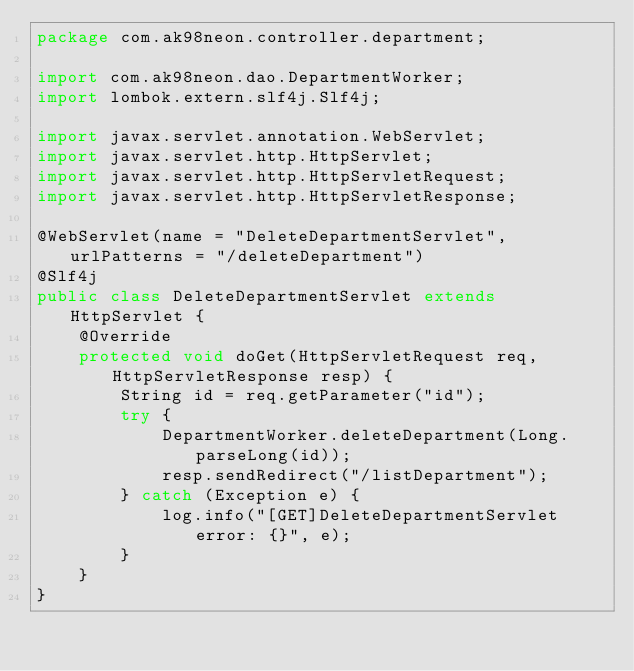<code> <loc_0><loc_0><loc_500><loc_500><_Java_>package com.ak98neon.controller.department;

import com.ak98neon.dao.DepartmentWorker;
import lombok.extern.slf4j.Slf4j;

import javax.servlet.annotation.WebServlet;
import javax.servlet.http.HttpServlet;
import javax.servlet.http.HttpServletRequest;
import javax.servlet.http.HttpServletResponse;

@WebServlet(name = "DeleteDepartmentServlet", urlPatterns = "/deleteDepartment")
@Slf4j
public class DeleteDepartmentServlet extends HttpServlet {
    @Override
    protected void doGet(HttpServletRequest req, HttpServletResponse resp) {
        String id = req.getParameter("id");
        try {
            DepartmentWorker.deleteDepartment(Long.parseLong(id));
            resp.sendRedirect("/listDepartment");
        } catch (Exception e) {
            log.info("[GET]DeleteDepartmentServlet error: {}", e);
        }
    }
}</code> 